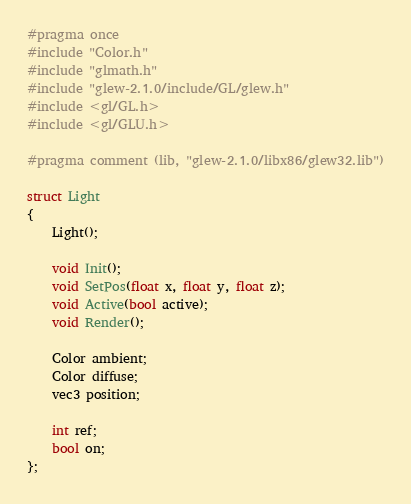<code> <loc_0><loc_0><loc_500><loc_500><_C_>
#pragma once
#include "Color.h"
#include "glmath.h"
#include "glew-2.1.0/include/GL/glew.h"
#include <gl/GL.h>
#include <gl/GLU.h>

#pragma comment (lib, "glew-2.1.0/libx86/glew32.lib")

struct Light
{
	Light();

	void Init();
	void SetPos(float x, float y, float z);
	void Active(bool active);
	void Render();

	Color ambient;
	Color diffuse;
	vec3 position;

	int ref;
	bool on;
};</code> 